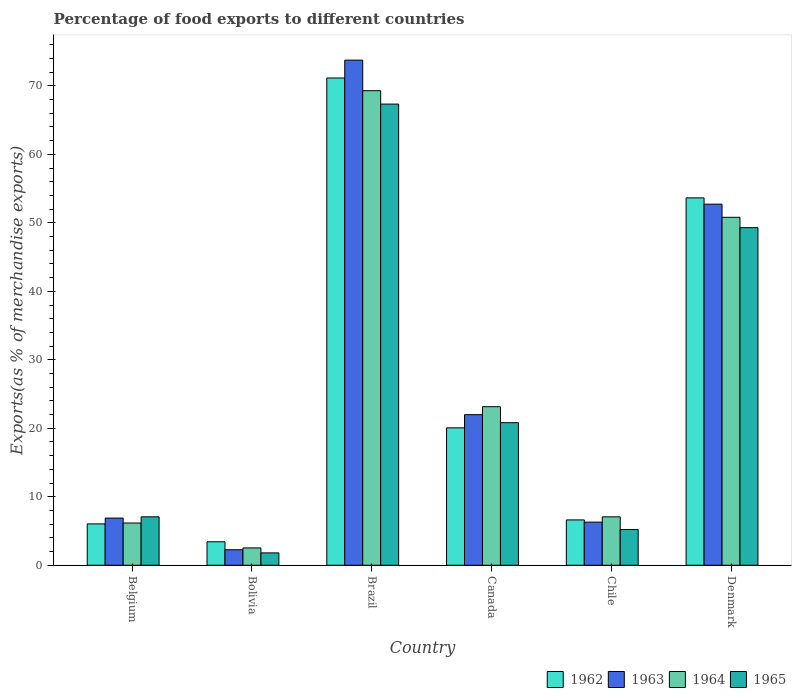Are the number of bars per tick equal to the number of legend labels?
Your answer should be compact. Yes. How many bars are there on the 1st tick from the left?
Your answer should be compact. 4. What is the label of the 2nd group of bars from the left?
Give a very brief answer. Bolivia. What is the percentage of exports to different countries in 1962 in Chile?
Your answer should be very brief. 6.62. Across all countries, what is the maximum percentage of exports to different countries in 1963?
Ensure brevity in your answer.  73.76. Across all countries, what is the minimum percentage of exports to different countries in 1962?
Provide a succinct answer. 3.43. What is the total percentage of exports to different countries in 1965 in the graph?
Your answer should be very brief. 151.55. What is the difference between the percentage of exports to different countries in 1964 in Canada and that in Denmark?
Keep it short and to the point. -27.65. What is the difference between the percentage of exports to different countries in 1962 in Belgium and the percentage of exports to different countries in 1965 in Bolivia?
Provide a succinct answer. 4.24. What is the average percentage of exports to different countries in 1962 per country?
Provide a succinct answer. 26.83. What is the difference between the percentage of exports to different countries of/in 1965 and percentage of exports to different countries of/in 1964 in Canada?
Your response must be concise. -2.34. In how many countries, is the percentage of exports to different countries in 1962 greater than 44 %?
Keep it short and to the point. 2. What is the ratio of the percentage of exports to different countries in 1964 in Bolivia to that in Denmark?
Offer a terse response. 0.05. Is the difference between the percentage of exports to different countries in 1965 in Bolivia and Brazil greater than the difference between the percentage of exports to different countries in 1964 in Bolivia and Brazil?
Your response must be concise. Yes. What is the difference between the highest and the second highest percentage of exports to different countries in 1964?
Your response must be concise. -18.49. What is the difference between the highest and the lowest percentage of exports to different countries in 1962?
Keep it short and to the point. 67.72. In how many countries, is the percentage of exports to different countries in 1965 greater than the average percentage of exports to different countries in 1965 taken over all countries?
Give a very brief answer. 2. Is the sum of the percentage of exports to different countries in 1964 in Belgium and Chile greater than the maximum percentage of exports to different countries in 1963 across all countries?
Your answer should be very brief. No. What does the 2nd bar from the right in Brazil represents?
Give a very brief answer. 1964. Is it the case that in every country, the sum of the percentage of exports to different countries in 1965 and percentage of exports to different countries in 1964 is greater than the percentage of exports to different countries in 1963?
Your answer should be compact. Yes. How many bars are there?
Offer a very short reply. 24. Are all the bars in the graph horizontal?
Your response must be concise. No. What is the difference between two consecutive major ticks on the Y-axis?
Your answer should be very brief. 10. Are the values on the major ticks of Y-axis written in scientific E-notation?
Offer a terse response. No. Where does the legend appear in the graph?
Give a very brief answer. Bottom right. How many legend labels are there?
Provide a succinct answer. 4. How are the legend labels stacked?
Your answer should be very brief. Horizontal. What is the title of the graph?
Your answer should be compact. Percentage of food exports to different countries. Does "2011" appear as one of the legend labels in the graph?
Provide a succinct answer. No. What is the label or title of the Y-axis?
Keep it short and to the point. Exports(as % of merchandise exports). What is the Exports(as % of merchandise exports) in 1962 in Belgium?
Offer a terse response. 6.04. What is the Exports(as % of merchandise exports) in 1963 in Belgium?
Your answer should be very brief. 6.89. What is the Exports(as % of merchandise exports) in 1964 in Belgium?
Your answer should be compact. 6.17. What is the Exports(as % of merchandise exports) in 1965 in Belgium?
Offer a terse response. 7.07. What is the Exports(as % of merchandise exports) in 1962 in Bolivia?
Provide a short and direct response. 3.43. What is the Exports(as % of merchandise exports) in 1963 in Bolivia?
Offer a terse response. 2.27. What is the Exports(as % of merchandise exports) in 1964 in Bolivia?
Your answer should be very brief. 2.53. What is the Exports(as % of merchandise exports) in 1965 in Bolivia?
Keep it short and to the point. 1.81. What is the Exports(as % of merchandise exports) of 1962 in Brazil?
Provide a succinct answer. 71.15. What is the Exports(as % of merchandise exports) of 1963 in Brazil?
Offer a terse response. 73.76. What is the Exports(as % of merchandise exports) of 1964 in Brazil?
Provide a succinct answer. 69.29. What is the Exports(as % of merchandise exports) in 1965 in Brazil?
Your answer should be compact. 67.34. What is the Exports(as % of merchandise exports) in 1962 in Canada?
Ensure brevity in your answer.  20.07. What is the Exports(as % of merchandise exports) in 1963 in Canada?
Provide a short and direct response. 21.99. What is the Exports(as % of merchandise exports) in 1964 in Canada?
Your response must be concise. 23.16. What is the Exports(as % of merchandise exports) in 1965 in Canada?
Offer a very short reply. 20.82. What is the Exports(as % of merchandise exports) of 1962 in Chile?
Offer a very short reply. 6.62. What is the Exports(as % of merchandise exports) in 1963 in Chile?
Ensure brevity in your answer.  6.3. What is the Exports(as % of merchandise exports) of 1964 in Chile?
Offer a very short reply. 7.07. What is the Exports(as % of merchandise exports) of 1965 in Chile?
Your answer should be very brief. 5.22. What is the Exports(as % of merchandise exports) of 1962 in Denmark?
Offer a very short reply. 53.65. What is the Exports(as % of merchandise exports) of 1963 in Denmark?
Offer a terse response. 52.73. What is the Exports(as % of merchandise exports) in 1964 in Denmark?
Offer a very short reply. 50.81. What is the Exports(as % of merchandise exports) in 1965 in Denmark?
Offer a terse response. 49.3. Across all countries, what is the maximum Exports(as % of merchandise exports) of 1962?
Your response must be concise. 71.15. Across all countries, what is the maximum Exports(as % of merchandise exports) in 1963?
Your answer should be compact. 73.76. Across all countries, what is the maximum Exports(as % of merchandise exports) in 1964?
Provide a succinct answer. 69.29. Across all countries, what is the maximum Exports(as % of merchandise exports) in 1965?
Ensure brevity in your answer.  67.34. Across all countries, what is the minimum Exports(as % of merchandise exports) in 1962?
Provide a succinct answer. 3.43. Across all countries, what is the minimum Exports(as % of merchandise exports) of 1963?
Your answer should be very brief. 2.27. Across all countries, what is the minimum Exports(as % of merchandise exports) of 1964?
Ensure brevity in your answer.  2.53. Across all countries, what is the minimum Exports(as % of merchandise exports) of 1965?
Make the answer very short. 1.81. What is the total Exports(as % of merchandise exports) of 1962 in the graph?
Make the answer very short. 160.96. What is the total Exports(as % of merchandise exports) in 1963 in the graph?
Offer a terse response. 163.93. What is the total Exports(as % of merchandise exports) of 1964 in the graph?
Provide a short and direct response. 159.03. What is the total Exports(as % of merchandise exports) in 1965 in the graph?
Your response must be concise. 151.55. What is the difference between the Exports(as % of merchandise exports) in 1962 in Belgium and that in Bolivia?
Offer a very short reply. 2.61. What is the difference between the Exports(as % of merchandise exports) in 1963 in Belgium and that in Bolivia?
Give a very brief answer. 4.62. What is the difference between the Exports(as % of merchandise exports) in 1964 in Belgium and that in Bolivia?
Provide a short and direct response. 3.64. What is the difference between the Exports(as % of merchandise exports) of 1965 in Belgium and that in Bolivia?
Provide a succinct answer. 5.27. What is the difference between the Exports(as % of merchandise exports) in 1962 in Belgium and that in Brazil?
Keep it short and to the point. -65.11. What is the difference between the Exports(as % of merchandise exports) in 1963 in Belgium and that in Brazil?
Offer a very short reply. -66.87. What is the difference between the Exports(as % of merchandise exports) of 1964 in Belgium and that in Brazil?
Provide a short and direct response. -63.12. What is the difference between the Exports(as % of merchandise exports) in 1965 in Belgium and that in Brazil?
Keep it short and to the point. -60.27. What is the difference between the Exports(as % of merchandise exports) in 1962 in Belgium and that in Canada?
Provide a succinct answer. -14.02. What is the difference between the Exports(as % of merchandise exports) of 1963 in Belgium and that in Canada?
Offer a terse response. -15.1. What is the difference between the Exports(as % of merchandise exports) in 1964 in Belgium and that in Canada?
Make the answer very short. -16.99. What is the difference between the Exports(as % of merchandise exports) in 1965 in Belgium and that in Canada?
Provide a short and direct response. -13.75. What is the difference between the Exports(as % of merchandise exports) in 1962 in Belgium and that in Chile?
Give a very brief answer. -0.58. What is the difference between the Exports(as % of merchandise exports) in 1963 in Belgium and that in Chile?
Offer a terse response. 0.59. What is the difference between the Exports(as % of merchandise exports) in 1964 in Belgium and that in Chile?
Your answer should be compact. -0.9. What is the difference between the Exports(as % of merchandise exports) in 1965 in Belgium and that in Chile?
Offer a very short reply. 1.86. What is the difference between the Exports(as % of merchandise exports) of 1962 in Belgium and that in Denmark?
Provide a succinct answer. -47.6. What is the difference between the Exports(as % of merchandise exports) of 1963 in Belgium and that in Denmark?
Provide a short and direct response. -45.84. What is the difference between the Exports(as % of merchandise exports) in 1964 in Belgium and that in Denmark?
Give a very brief answer. -44.64. What is the difference between the Exports(as % of merchandise exports) in 1965 in Belgium and that in Denmark?
Provide a succinct answer. -42.22. What is the difference between the Exports(as % of merchandise exports) in 1962 in Bolivia and that in Brazil?
Offer a very short reply. -67.72. What is the difference between the Exports(as % of merchandise exports) in 1963 in Bolivia and that in Brazil?
Provide a succinct answer. -71.49. What is the difference between the Exports(as % of merchandise exports) of 1964 in Bolivia and that in Brazil?
Give a very brief answer. -66.76. What is the difference between the Exports(as % of merchandise exports) in 1965 in Bolivia and that in Brazil?
Your response must be concise. -65.53. What is the difference between the Exports(as % of merchandise exports) of 1962 in Bolivia and that in Canada?
Make the answer very short. -16.64. What is the difference between the Exports(as % of merchandise exports) of 1963 in Bolivia and that in Canada?
Ensure brevity in your answer.  -19.72. What is the difference between the Exports(as % of merchandise exports) in 1964 in Bolivia and that in Canada?
Offer a terse response. -20.62. What is the difference between the Exports(as % of merchandise exports) of 1965 in Bolivia and that in Canada?
Make the answer very short. -19.01. What is the difference between the Exports(as % of merchandise exports) in 1962 in Bolivia and that in Chile?
Your response must be concise. -3.19. What is the difference between the Exports(as % of merchandise exports) of 1963 in Bolivia and that in Chile?
Make the answer very short. -4.03. What is the difference between the Exports(as % of merchandise exports) of 1964 in Bolivia and that in Chile?
Make the answer very short. -4.54. What is the difference between the Exports(as % of merchandise exports) of 1965 in Bolivia and that in Chile?
Make the answer very short. -3.41. What is the difference between the Exports(as % of merchandise exports) in 1962 in Bolivia and that in Denmark?
Make the answer very short. -50.22. What is the difference between the Exports(as % of merchandise exports) of 1963 in Bolivia and that in Denmark?
Ensure brevity in your answer.  -50.46. What is the difference between the Exports(as % of merchandise exports) of 1964 in Bolivia and that in Denmark?
Your answer should be very brief. -48.27. What is the difference between the Exports(as % of merchandise exports) in 1965 in Bolivia and that in Denmark?
Offer a very short reply. -47.49. What is the difference between the Exports(as % of merchandise exports) in 1962 in Brazil and that in Canada?
Ensure brevity in your answer.  51.08. What is the difference between the Exports(as % of merchandise exports) of 1963 in Brazil and that in Canada?
Give a very brief answer. 51.77. What is the difference between the Exports(as % of merchandise exports) in 1964 in Brazil and that in Canada?
Ensure brevity in your answer.  46.14. What is the difference between the Exports(as % of merchandise exports) of 1965 in Brazil and that in Canada?
Make the answer very short. 46.52. What is the difference between the Exports(as % of merchandise exports) of 1962 in Brazil and that in Chile?
Offer a very short reply. 64.53. What is the difference between the Exports(as % of merchandise exports) of 1963 in Brazil and that in Chile?
Give a very brief answer. 67.46. What is the difference between the Exports(as % of merchandise exports) in 1964 in Brazil and that in Chile?
Offer a terse response. 62.22. What is the difference between the Exports(as % of merchandise exports) in 1965 in Brazil and that in Chile?
Your answer should be compact. 62.12. What is the difference between the Exports(as % of merchandise exports) in 1962 in Brazil and that in Denmark?
Your answer should be compact. 17.5. What is the difference between the Exports(as % of merchandise exports) in 1963 in Brazil and that in Denmark?
Give a very brief answer. 21.03. What is the difference between the Exports(as % of merchandise exports) in 1964 in Brazil and that in Denmark?
Ensure brevity in your answer.  18.49. What is the difference between the Exports(as % of merchandise exports) of 1965 in Brazil and that in Denmark?
Your response must be concise. 18.04. What is the difference between the Exports(as % of merchandise exports) of 1962 in Canada and that in Chile?
Make the answer very short. 13.45. What is the difference between the Exports(as % of merchandise exports) in 1963 in Canada and that in Chile?
Offer a very short reply. 15.69. What is the difference between the Exports(as % of merchandise exports) of 1964 in Canada and that in Chile?
Your answer should be compact. 16.09. What is the difference between the Exports(as % of merchandise exports) in 1965 in Canada and that in Chile?
Your response must be concise. 15.6. What is the difference between the Exports(as % of merchandise exports) of 1962 in Canada and that in Denmark?
Ensure brevity in your answer.  -33.58. What is the difference between the Exports(as % of merchandise exports) of 1963 in Canada and that in Denmark?
Offer a very short reply. -30.74. What is the difference between the Exports(as % of merchandise exports) of 1964 in Canada and that in Denmark?
Keep it short and to the point. -27.65. What is the difference between the Exports(as % of merchandise exports) of 1965 in Canada and that in Denmark?
Provide a short and direct response. -28.48. What is the difference between the Exports(as % of merchandise exports) of 1962 in Chile and that in Denmark?
Your answer should be very brief. -47.02. What is the difference between the Exports(as % of merchandise exports) in 1963 in Chile and that in Denmark?
Offer a terse response. -46.43. What is the difference between the Exports(as % of merchandise exports) in 1964 in Chile and that in Denmark?
Offer a very short reply. -43.74. What is the difference between the Exports(as % of merchandise exports) of 1965 in Chile and that in Denmark?
Make the answer very short. -44.08. What is the difference between the Exports(as % of merchandise exports) in 1962 in Belgium and the Exports(as % of merchandise exports) in 1963 in Bolivia?
Ensure brevity in your answer.  3.78. What is the difference between the Exports(as % of merchandise exports) in 1962 in Belgium and the Exports(as % of merchandise exports) in 1964 in Bolivia?
Offer a very short reply. 3.51. What is the difference between the Exports(as % of merchandise exports) in 1962 in Belgium and the Exports(as % of merchandise exports) in 1965 in Bolivia?
Provide a short and direct response. 4.24. What is the difference between the Exports(as % of merchandise exports) of 1963 in Belgium and the Exports(as % of merchandise exports) of 1964 in Bolivia?
Offer a terse response. 4.36. What is the difference between the Exports(as % of merchandise exports) of 1963 in Belgium and the Exports(as % of merchandise exports) of 1965 in Bolivia?
Your answer should be compact. 5.08. What is the difference between the Exports(as % of merchandise exports) in 1964 in Belgium and the Exports(as % of merchandise exports) in 1965 in Bolivia?
Your response must be concise. 4.36. What is the difference between the Exports(as % of merchandise exports) in 1962 in Belgium and the Exports(as % of merchandise exports) in 1963 in Brazil?
Give a very brief answer. -67.71. What is the difference between the Exports(as % of merchandise exports) in 1962 in Belgium and the Exports(as % of merchandise exports) in 1964 in Brazil?
Make the answer very short. -63.25. What is the difference between the Exports(as % of merchandise exports) of 1962 in Belgium and the Exports(as % of merchandise exports) of 1965 in Brazil?
Offer a terse response. -61.3. What is the difference between the Exports(as % of merchandise exports) of 1963 in Belgium and the Exports(as % of merchandise exports) of 1964 in Brazil?
Make the answer very short. -62.4. What is the difference between the Exports(as % of merchandise exports) in 1963 in Belgium and the Exports(as % of merchandise exports) in 1965 in Brazil?
Offer a very short reply. -60.45. What is the difference between the Exports(as % of merchandise exports) of 1964 in Belgium and the Exports(as % of merchandise exports) of 1965 in Brazil?
Ensure brevity in your answer.  -61.17. What is the difference between the Exports(as % of merchandise exports) of 1962 in Belgium and the Exports(as % of merchandise exports) of 1963 in Canada?
Give a very brief answer. -15.95. What is the difference between the Exports(as % of merchandise exports) of 1962 in Belgium and the Exports(as % of merchandise exports) of 1964 in Canada?
Your response must be concise. -17.11. What is the difference between the Exports(as % of merchandise exports) in 1962 in Belgium and the Exports(as % of merchandise exports) in 1965 in Canada?
Your answer should be very brief. -14.78. What is the difference between the Exports(as % of merchandise exports) in 1963 in Belgium and the Exports(as % of merchandise exports) in 1964 in Canada?
Your answer should be compact. -16.27. What is the difference between the Exports(as % of merchandise exports) of 1963 in Belgium and the Exports(as % of merchandise exports) of 1965 in Canada?
Your answer should be compact. -13.93. What is the difference between the Exports(as % of merchandise exports) of 1964 in Belgium and the Exports(as % of merchandise exports) of 1965 in Canada?
Provide a succinct answer. -14.65. What is the difference between the Exports(as % of merchandise exports) in 1962 in Belgium and the Exports(as % of merchandise exports) in 1963 in Chile?
Your response must be concise. -0.26. What is the difference between the Exports(as % of merchandise exports) of 1962 in Belgium and the Exports(as % of merchandise exports) of 1964 in Chile?
Ensure brevity in your answer.  -1.03. What is the difference between the Exports(as % of merchandise exports) in 1962 in Belgium and the Exports(as % of merchandise exports) in 1965 in Chile?
Make the answer very short. 0.83. What is the difference between the Exports(as % of merchandise exports) in 1963 in Belgium and the Exports(as % of merchandise exports) in 1964 in Chile?
Provide a succinct answer. -0.18. What is the difference between the Exports(as % of merchandise exports) in 1963 in Belgium and the Exports(as % of merchandise exports) in 1965 in Chile?
Give a very brief answer. 1.67. What is the difference between the Exports(as % of merchandise exports) in 1964 in Belgium and the Exports(as % of merchandise exports) in 1965 in Chile?
Keep it short and to the point. 0.95. What is the difference between the Exports(as % of merchandise exports) in 1962 in Belgium and the Exports(as % of merchandise exports) in 1963 in Denmark?
Provide a succinct answer. -46.69. What is the difference between the Exports(as % of merchandise exports) in 1962 in Belgium and the Exports(as % of merchandise exports) in 1964 in Denmark?
Offer a very short reply. -44.76. What is the difference between the Exports(as % of merchandise exports) in 1962 in Belgium and the Exports(as % of merchandise exports) in 1965 in Denmark?
Ensure brevity in your answer.  -43.25. What is the difference between the Exports(as % of merchandise exports) of 1963 in Belgium and the Exports(as % of merchandise exports) of 1964 in Denmark?
Offer a terse response. -43.92. What is the difference between the Exports(as % of merchandise exports) in 1963 in Belgium and the Exports(as % of merchandise exports) in 1965 in Denmark?
Your answer should be compact. -42.41. What is the difference between the Exports(as % of merchandise exports) in 1964 in Belgium and the Exports(as % of merchandise exports) in 1965 in Denmark?
Keep it short and to the point. -43.13. What is the difference between the Exports(as % of merchandise exports) of 1962 in Bolivia and the Exports(as % of merchandise exports) of 1963 in Brazil?
Offer a terse response. -70.33. What is the difference between the Exports(as % of merchandise exports) in 1962 in Bolivia and the Exports(as % of merchandise exports) in 1964 in Brazil?
Your answer should be compact. -65.86. What is the difference between the Exports(as % of merchandise exports) in 1962 in Bolivia and the Exports(as % of merchandise exports) in 1965 in Brazil?
Your answer should be compact. -63.91. What is the difference between the Exports(as % of merchandise exports) in 1963 in Bolivia and the Exports(as % of merchandise exports) in 1964 in Brazil?
Make the answer very short. -67.03. What is the difference between the Exports(as % of merchandise exports) of 1963 in Bolivia and the Exports(as % of merchandise exports) of 1965 in Brazil?
Give a very brief answer. -65.07. What is the difference between the Exports(as % of merchandise exports) of 1964 in Bolivia and the Exports(as % of merchandise exports) of 1965 in Brazil?
Offer a very short reply. -64.81. What is the difference between the Exports(as % of merchandise exports) in 1962 in Bolivia and the Exports(as % of merchandise exports) in 1963 in Canada?
Offer a very short reply. -18.56. What is the difference between the Exports(as % of merchandise exports) in 1962 in Bolivia and the Exports(as % of merchandise exports) in 1964 in Canada?
Your response must be concise. -19.73. What is the difference between the Exports(as % of merchandise exports) in 1962 in Bolivia and the Exports(as % of merchandise exports) in 1965 in Canada?
Provide a short and direct response. -17.39. What is the difference between the Exports(as % of merchandise exports) in 1963 in Bolivia and the Exports(as % of merchandise exports) in 1964 in Canada?
Provide a succinct answer. -20.89. What is the difference between the Exports(as % of merchandise exports) in 1963 in Bolivia and the Exports(as % of merchandise exports) in 1965 in Canada?
Provide a short and direct response. -18.55. What is the difference between the Exports(as % of merchandise exports) in 1964 in Bolivia and the Exports(as % of merchandise exports) in 1965 in Canada?
Provide a short and direct response. -18.29. What is the difference between the Exports(as % of merchandise exports) of 1962 in Bolivia and the Exports(as % of merchandise exports) of 1963 in Chile?
Your answer should be very brief. -2.87. What is the difference between the Exports(as % of merchandise exports) in 1962 in Bolivia and the Exports(as % of merchandise exports) in 1964 in Chile?
Ensure brevity in your answer.  -3.64. What is the difference between the Exports(as % of merchandise exports) in 1962 in Bolivia and the Exports(as % of merchandise exports) in 1965 in Chile?
Your answer should be very brief. -1.79. What is the difference between the Exports(as % of merchandise exports) of 1963 in Bolivia and the Exports(as % of merchandise exports) of 1964 in Chile?
Your response must be concise. -4.8. What is the difference between the Exports(as % of merchandise exports) in 1963 in Bolivia and the Exports(as % of merchandise exports) in 1965 in Chile?
Give a very brief answer. -2.95. What is the difference between the Exports(as % of merchandise exports) in 1964 in Bolivia and the Exports(as % of merchandise exports) in 1965 in Chile?
Make the answer very short. -2.69. What is the difference between the Exports(as % of merchandise exports) in 1962 in Bolivia and the Exports(as % of merchandise exports) in 1963 in Denmark?
Ensure brevity in your answer.  -49.3. What is the difference between the Exports(as % of merchandise exports) in 1962 in Bolivia and the Exports(as % of merchandise exports) in 1964 in Denmark?
Keep it short and to the point. -47.38. What is the difference between the Exports(as % of merchandise exports) of 1962 in Bolivia and the Exports(as % of merchandise exports) of 1965 in Denmark?
Make the answer very short. -45.87. What is the difference between the Exports(as % of merchandise exports) of 1963 in Bolivia and the Exports(as % of merchandise exports) of 1964 in Denmark?
Give a very brief answer. -48.54. What is the difference between the Exports(as % of merchandise exports) of 1963 in Bolivia and the Exports(as % of merchandise exports) of 1965 in Denmark?
Keep it short and to the point. -47.03. What is the difference between the Exports(as % of merchandise exports) of 1964 in Bolivia and the Exports(as % of merchandise exports) of 1965 in Denmark?
Keep it short and to the point. -46.77. What is the difference between the Exports(as % of merchandise exports) in 1962 in Brazil and the Exports(as % of merchandise exports) in 1963 in Canada?
Keep it short and to the point. 49.16. What is the difference between the Exports(as % of merchandise exports) of 1962 in Brazil and the Exports(as % of merchandise exports) of 1964 in Canada?
Provide a short and direct response. 47.99. What is the difference between the Exports(as % of merchandise exports) of 1962 in Brazil and the Exports(as % of merchandise exports) of 1965 in Canada?
Provide a succinct answer. 50.33. What is the difference between the Exports(as % of merchandise exports) of 1963 in Brazil and the Exports(as % of merchandise exports) of 1964 in Canada?
Your response must be concise. 50.6. What is the difference between the Exports(as % of merchandise exports) in 1963 in Brazil and the Exports(as % of merchandise exports) in 1965 in Canada?
Your answer should be compact. 52.94. What is the difference between the Exports(as % of merchandise exports) in 1964 in Brazil and the Exports(as % of merchandise exports) in 1965 in Canada?
Give a very brief answer. 48.48. What is the difference between the Exports(as % of merchandise exports) of 1962 in Brazil and the Exports(as % of merchandise exports) of 1963 in Chile?
Ensure brevity in your answer.  64.85. What is the difference between the Exports(as % of merchandise exports) in 1962 in Brazil and the Exports(as % of merchandise exports) in 1964 in Chile?
Keep it short and to the point. 64.08. What is the difference between the Exports(as % of merchandise exports) of 1962 in Brazil and the Exports(as % of merchandise exports) of 1965 in Chile?
Offer a very short reply. 65.93. What is the difference between the Exports(as % of merchandise exports) of 1963 in Brazil and the Exports(as % of merchandise exports) of 1964 in Chile?
Ensure brevity in your answer.  66.69. What is the difference between the Exports(as % of merchandise exports) in 1963 in Brazil and the Exports(as % of merchandise exports) in 1965 in Chile?
Provide a short and direct response. 68.54. What is the difference between the Exports(as % of merchandise exports) of 1964 in Brazil and the Exports(as % of merchandise exports) of 1965 in Chile?
Provide a short and direct response. 64.08. What is the difference between the Exports(as % of merchandise exports) in 1962 in Brazil and the Exports(as % of merchandise exports) in 1963 in Denmark?
Your answer should be compact. 18.42. What is the difference between the Exports(as % of merchandise exports) in 1962 in Brazil and the Exports(as % of merchandise exports) in 1964 in Denmark?
Keep it short and to the point. 20.34. What is the difference between the Exports(as % of merchandise exports) in 1962 in Brazil and the Exports(as % of merchandise exports) in 1965 in Denmark?
Give a very brief answer. 21.85. What is the difference between the Exports(as % of merchandise exports) of 1963 in Brazil and the Exports(as % of merchandise exports) of 1964 in Denmark?
Give a very brief answer. 22.95. What is the difference between the Exports(as % of merchandise exports) of 1963 in Brazil and the Exports(as % of merchandise exports) of 1965 in Denmark?
Give a very brief answer. 24.46. What is the difference between the Exports(as % of merchandise exports) of 1964 in Brazil and the Exports(as % of merchandise exports) of 1965 in Denmark?
Offer a terse response. 20. What is the difference between the Exports(as % of merchandise exports) of 1962 in Canada and the Exports(as % of merchandise exports) of 1963 in Chile?
Provide a succinct answer. 13.77. What is the difference between the Exports(as % of merchandise exports) in 1962 in Canada and the Exports(as % of merchandise exports) in 1964 in Chile?
Make the answer very short. 13. What is the difference between the Exports(as % of merchandise exports) of 1962 in Canada and the Exports(as % of merchandise exports) of 1965 in Chile?
Provide a succinct answer. 14.85. What is the difference between the Exports(as % of merchandise exports) in 1963 in Canada and the Exports(as % of merchandise exports) in 1964 in Chile?
Give a very brief answer. 14.92. What is the difference between the Exports(as % of merchandise exports) of 1963 in Canada and the Exports(as % of merchandise exports) of 1965 in Chile?
Keep it short and to the point. 16.77. What is the difference between the Exports(as % of merchandise exports) in 1964 in Canada and the Exports(as % of merchandise exports) in 1965 in Chile?
Make the answer very short. 17.94. What is the difference between the Exports(as % of merchandise exports) of 1962 in Canada and the Exports(as % of merchandise exports) of 1963 in Denmark?
Ensure brevity in your answer.  -32.66. What is the difference between the Exports(as % of merchandise exports) in 1962 in Canada and the Exports(as % of merchandise exports) in 1964 in Denmark?
Keep it short and to the point. -30.74. What is the difference between the Exports(as % of merchandise exports) in 1962 in Canada and the Exports(as % of merchandise exports) in 1965 in Denmark?
Offer a terse response. -29.23. What is the difference between the Exports(as % of merchandise exports) of 1963 in Canada and the Exports(as % of merchandise exports) of 1964 in Denmark?
Ensure brevity in your answer.  -28.82. What is the difference between the Exports(as % of merchandise exports) of 1963 in Canada and the Exports(as % of merchandise exports) of 1965 in Denmark?
Make the answer very short. -27.31. What is the difference between the Exports(as % of merchandise exports) of 1964 in Canada and the Exports(as % of merchandise exports) of 1965 in Denmark?
Keep it short and to the point. -26.14. What is the difference between the Exports(as % of merchandise exports) in 1962 in Chile and the Exports(as % of merchandise exports) in 1963 in Denmark?
Keep it short and to the point. -46.11. What is the difference between the Exports(as % of merchandise exports) in 1962 in Chile and the Exports(as % of merchandise exports) in 1964 in Denmark?
Make the answer very short. -44.19. What is the difference between the Exports(as % of merchandise exports) of 1962 in Chile and the Exports(as % of merchandise exports) of 1965 in Denmark?
Your response must be concise. -42.68. What is the difference between the Exports(as % of merchandise exports) in 1963 in Chile and the Exports(as % of merchandise exports) in 1964 in Denmark?
Give a very brief answer. -44.51. What is the difference between the Exports(as % of merchandise exports) of 1963 in Chile and the Exports(as % of merchandise exports) of 1965 in Denmark?
Offer a terse response. -43. What is the difference between the Exports(as % of merchandise exports) in 1964 in Chile and the Exports(as % of merchandise exports) in 1965 in Denmark?
Make the answer very short. -42.23. What is the average Exports(as % of merchandise exports) of 1962 per country?
Keep it short and to the point. 26.83. What is the average Exports(as % of merchandise exports) in 1963 per country?
Provide a succinct answer. 27.32. What is the average Exports(as % of merchandise exports) in 1964 per country?
Keep it short and to the point. 26.5. What is the average Exports(as % of merchandise exports) of 1965 per country?
Make the answer very short. 25.26. What is the difference between the Exports(as % of merchandise exports) in 1962 and Exports(as % of merchandise exports) in 1963 in Belgium?
Offer a terse response. -0.85. What is the difference between the Exports(as % of merchandise exports) in 1962 and Exports(as % of merchandise exports) in 1964 in Belgium?
Offer a terse response. -0.13. What is the difference between the Exports(as % of merchandise exports) in 1962 and Exports(as % of merchandise exports) in 1965 in Belgium?
Provide a succinct answer. -1.03. What is the difference between the Exports(as % of merchandise exports) of 1963 and Exports(as % of merchandise exports) of 1964 in Belgium?
Your response must be concise. 0.72. What is the difference between the Exports(as % of merchandise exports) in 1963 and Exports(as % of merchandise exports) in 1965 in Belgium?
Make the answer very short. -0.18. What is the difference between the Exports(as % of merchandise exports) of 1964 and Exports(as % of merchandise exports) of 1965 in Belgium?
Make the answer very short. -0.9. What is the difference between the Exports(as % of merchandise exports) in 1962 and Exports(as % of merchandise exports) in 1963 in Bolivia?
Your answer should be very brief. 1.16. What is the difference between the Exports(as % of merchandise exports) of 1962 and Exports(as % of merchandise exports) of 1964 in Bolivia?
Give a very brief answer. 0.9. What is the difference between the Exports(as % of merchandise exports) in 1962 and Exports(as % of merchandise exports) in 1965 in Bolivia?
Provide a short and direct response. 1.62. What is the difference between the Exports(as % of merchandise exports) in 1963 and Exports(as % of merchandise exports) in 1964 in Bolivia?
Make the answer very short. -0.27. What is the difference between the Exports(as % of merchandise exports) of 1963 and Exports(as % of merchandise exports) of 1965 in Bolivia?
Make the answer very short. 0.46. What is the difference between the Exports(as % of merchandise exports) of 1964 and Exports(as % of merchandise exports) of 1965 in Bolivia?
Make the answer very short. 0.73. What is the difference between the Exports(as % of merchandise exports) of 1962 and Exports(as % of merchandise exports) of 1963 in Brazil?
Ensure brevity in your answer.  -2.61. What is the difference between the Exports(as % of merchandise exports) of 1962 and Exports(as % of merchandise exports) of 1964 in Brazil?
Keep it short and to the point. 1.86. What is the difference between the Exports(as % of merchandise exports) in 1962 and Exports(as % of merchandise exports) in 1965 in Brazil?
Provide a succinct answer. 3.81. What is the difference between the Exports(as % of merchandise exports) of 1963 and Exports(as % of merchandise exports) of 1964 in Brazil?
Keep it short and to the point. 4.46. What is the difference between the Exports(as % of merchandise exports) of 1963 and Exports(as % of merchandise exports) of 1965 in Brazil?
Offer a very short reply. 6.42. What is the difference between the Exports(as % of merchandise exports) of 1964 and Exports(as % of merchandise exports) of 1965 in Brazil?
Offer a very short reply. 1.96. What is the difference between the Exports(as % of merchandise exports) of 1962 and Exports(as % of merchandise exports) of 1963 in Canada?
Make the answer very short. -1.92. What is the difference between the Exports(as % of merchandise exports) in 1962 and Exports(as % of merchandise exports) in 1964 in Canada?
Offer a very short reply. -3.09. What is the difference between the Exports(as % of merchandise exports) in 1962 and Exports(as % of merchandise exports) in 1965 in Canada?
Provide a short and direct response. -0.75. What is the difference between the Exports(as % of merchandise exports) of 1963 and Exports(as % of merchandise exports) of 1964 in Canada?
Your answer should be compact. -1.17. What is the difference between the Exports(as % of merchandise exports) in 1963 and Exports(as % of merchandise exports) in 1965 in Canada?
Offer a very short reply. 1.17. What is the difference between the Exports(as % of merchandise exports) of 1964 and Exports(as % of merchandise exports) of 1965 in Canada?
Offer a very short reply. 2.34. What is the difference between the Exports(as % of merchandise exports) of 1962 and Exports(as % of merchandise exports) of 1963 in Chile?
Offer a terse response. 0.32. What is the difference between the Exports(as % of merchandise exports) in 1962 and Exports(as % of merchandise exports) in 1964 in Chile?
Offer a terse response. -0.45. What is the difference between the Exports(as % of merchandise exports) of 1962 and Exports(as % of merchandise exports) of 1965 in Chile?
Provide a succinct answer. 1.4. What is the difference between the Exports(as % of merchandise exports) of 1963 and Exports(as % of merchandise exports) of 1964 in Chile?
Ensure brevity in your answer.  -0.77. What is the difference between the Exports(as % of merchandise exports) in 1963 and Exports(as % of merchandise exports) in 1965 in Chile?
Offer a very short reply. 1.08. What is the difference between the Exports(as % of merchandise exports) of 1964 and Exports(as % of merchandise exports) of 1965 in Chile?
Provide a succinct answer. 1.85. What is the difference between the Exports(as % of merchandise exports) in 1962 and Exports(as % of merchandise exports) in 1963 in Denmark?
Provide a succinct answer. 0.92. What is the difference between the Exports(as % of merchandise exports) of 1962 and Exports(as % of merchandise exports) of 1964 in Denmark?
Offer a very short reply. 2.84. What is the difference between the Exports(as % of merchandise exports) of 1962 and Exports(as % of merchandise exports) of 1965 in Denmark?
Your answer should be very brief. 4.35. What is the difference between the Exports(as % of merchandise exports) in 1963 and Exports(as % of merchandise exports) in 1964 in Denmark?
Ensure brevity in your answer.  1.92. What is the difference between the Exports(as % of merchandise exports) in 1963 and Exports(as % of merchandise exports) in 1965 in Denmark?
Make the answer very short. 3.43. What is the difference between the Exports(as % of merchandise exports) in 1964 and Exports(as % of merchandise exports) in 1965 in Denmark?
Make the answer very short. 1.51. What is the ratio of the Exports(as % of merchandise exports) of 1962 in Belgium to that in Bolivia?
Keep it short and to the point. 1.76. What is the ratio of the Exports(as % of merchandise exports) of 1963 in Belgium to that in Bolivia?
Make the answer very short. 3.04. What is the ratio of the Exports(as % of merchandise exports) in 1964 in Belgium to that in Bolivia?
Offer a terse response. 2.44. What is the ratio of the Exports(as % of merchandise exports) in 1965 in Belgium to that in Bolivia?
Make the answer very short. 3.91. What is the ratio of the Exports(as % of merchandise exports) in 1962 in Belgium to that in Brazil?
Provide a succinct answer. 0.08. What is the ratio of the Exports(as % of merchandise exports) in 1963 in Belgium to that in Brazil?
Your answer should be very brief. 0.09. What is the ratio of the Exports(as % of merchandise exports) in 1964 in Belgium to that in Brazil?
Keep it short and to the point. 0.09. What is the ratio of the Exports(as % of merchandise exports) in 1965 in Belgium to that in Brazil?
Ensure brevity in your answer.  0.1. What is the ratio of the Exports(as % of merchandise exports) of 1962 in Belgium to that in Canada?
Offer a terse response. 0.3. What is the ratio of the Exports(as % of merchandise exports) in 1963 in Belgium to that in Canada?
Give a very brief answer. 0.31. What is the ratio of the Exports(as % of merchandise exports) in 1964 in Belgium to that in Canada?
Your answer should be very brief. 0.27. What is the ratio of the Exports(as % of merchandise exports) of 1965 in Belgium to that in Canada?
Provide a short and direct response. 0.34. What is the ratio of the Exports(as % of merchandise exports) in 1962 in Belgium to that in Chile?
Ensure brevity in your answer.  0.91. What is the ratio of the Exports(as % of merchandise exports) of 1963 in Belgium to that in Chile?
Your answer should be compact. 1.09. What is the ratio of the Exports(as % of merchandise exports) in 1964 in Belgium to that in Chile?
Your answer should be very brief. 0.87. What is the ratio of the Exports(as % of merchandise exports) of 1965 in Belgium to that in Chile?
Make the answer very short. 1.36. What is the ratio of the Exports(as % of merchandise exports) of 1962 in Belgium to that in Denmark?
Make the answer very short. 0.11. What is the ratio of the Exports(as % of merchandise exports) in 1963 in Belgium to that in Denmark?
Ensure brevity in your answer.  0.13. What is the ratio of the Exports(as % of merchandise exports) of 1964 in Belgium to that in Denmark?
Your response must be concise. 0.12. What is the ratio of the Exports(as % of merchandise exports) of 1965 in Belgium to that in Denmark?
Provide a succinct answer. 0.14. What is the ratio of the Exports(as % of merchandise exports) of 1962 in Bolivia to that in Brazil?
Make the answer very short. 0.05. What is the ratio of the Exports(as % of merchandise exports) of 1963 in Bolivia to that in Brazil?
Your answer should be compact. 0.03. What is the ratio of the Exports(as % of merchandise exports) in 1964 in Bolivia to that in Brazil?
Make the answer very short. 0.04. What is the ratio of the Exports(as % of merchandise exports) in 1965 in Bolivia to that in Brazil?
Ensure brevity in your answer.  0.03. What is the ratio of the Exports(as % of merchandise exports) of 1962 in Bolivia to that in Canada?
Your answer should be compact. 0.17. What is the ratio of the Exports(as % of merchandise exports) of 1963 in Bolivia to that in Canada?
Provide a short and direct response. 0.1. What is the ratio of the Exports(as % of merchandise exports) in 1964 in Bolivia to that in Canada?
Offer a terse response. 0.11. What is the ratio of the Exports(as % of merchandise exports) in 1965 in Bolivia to that in Canada?
Make the answer very short. 0.09. What is the ratio of the Exports(as % of merchandise exports) in 1962 in Bolivia to that in Chile?
Your answer should be very brief. 0.52. What is the ratio of the Exports(as % of merchandise exports) of 1963 in Bolivia to that in Chile?
Provide a succinct answer. 0.36. What is the ratio of the Exports(as % of merchandise exports) in 1964 in Bolivia to that in Chile?
Offer a terse response. 0.36. What is the ratio of the Exports(as % of merchandise exports) in 1965 in Bolivia to that in Chile?
Your answer should be compact. 0.35. What is the ratio of the Exports(as % of merchandise exports) of 1962 in Bolivia to that in Denmark?
Make the answer very short. 0.06. What is the ratio of the Exports(as % of merchandise exports) in 1963 in Bolivia to that in Denmark?
Your answer should be very brief. 0.04. What is the ratio of the Exports(as % of merchandise exports) in 1964 in Bolivia to that in Denmark?
Give a very brief answer. 0.05. What is the ratio of the Exports(as % of merchandise exports) of 1965 in Bolivia to that in Denmark?
Your response must be concise. 0.04. What is the ratio of the Exports(as % of merchandise exports) in 1962 in Brazil to that in Canada?
Offer a very short reply. 3.55. What is the ratio of the Exports(as % of merchandise exports) of 1963 in Brazil to that in Canada?
Make the answer very short. 3.35. What is the ratio of the Exports(as % of merchandise exports) in 1964 in Brazil to that in Canada?
Your answer should be very brief. 2.99. What is the ratio of the Exports(as % of merchandise exports) of 1965 in Brazil to that in Canada?
Provide a short and direct response. 3.23. What is the ratio of the Exports(as % of merchandise exports) in 1962 in Brazil to that in Chile?
Offer a terse response. 10.75. What is the ratio of the Exports(as % of merchandise exports) in 1963 in Brazil to that in Chile?
Offer a very short reply. 11.71. What is the ratio of the Exports(as % of merchandise exports) in 1964 in Brazil to that in Chile?
Ensure brevity in your answer.  9.8. What is the ratio of the Exports(as % of merchandise exports) in 1965 in Brazil to that in Chile?
Your answer should be compact. 12.91. What is the ratio of the Exports(as % of merchandise exports) of 1962 in Brazil to that in Denmark?
Offer a very short reply. 1.33. What is the ratio of the Exports(as % of merchandise exports) of 1963 in Brazil to that in Denmark?
Keep it short and to the point. 1.4. What is the ratio of the Exports(as % of merchandise exports) of 1964 in Brazil to that in Denmark?
Your response must be concise. 1.36. What is the ratio of the Exports(as % of merchandise exports) in 1965 in Brazil to that in Denmark?
Provide a short and direct response. 1.37. What is the ratio of the Exports(as % of merchandise exports) of 1962 in Canada to that in Chile?
Your response must be concise. 3.03. What is the ratio of the Exports(as % of merchandise exports) in 1963 in Canada to that in Chile?
Your response must be concise. 3.49. What is the ratio of the Exports(as % of merchandise exports) in 1964 in Canada to that in Chile?
Your answer should be compact. 3.28. What is the ratio of the Exports(as % of merchandise exports) of 1965 in Canada to that in Chile?
Your answer should be very brief. 3.99. What is the ratio of the Exports(as % of merchandise exports) of 1962 in Canada to that in Denmark?
Make the answer very short. 0.37. What is the ratio of the Exports(as % of merchandise exports) in 1963 in Canada to that in Denmark?
Your answer should be compact. 0.42. What is the ratio of the Exports(as % of merchandise exports) of 1964 in Canada to that in Denmark?
Ensure brevity in your answer.  0.46. What is the ratio of the Exports(as % of merchandise exports) in 1965 in Canada to that in Denmark?
Offer a very short reply. 0.42. What is the ratio of the Exports(as % of merchandise exports) of 1962 in Chile to that in Denmark?
Your answer should be compact. 0.12. What is the ratio of the Exports(as % of merchandise exports) in 1963 in Chile to that in Denmark?
Your answer should be very brief. 0.12. What is the ratio of the Exports(as % of merchandise exports) of 1964 in Chile to that in Denmark?
Keep it short and to the point. 0.14. What is the ratio of the Exports(as % of merchandise exports) in 1965 in Chile to that in Denmark?
Offer a very short reply. 0.11. What is the difference between the highest and the second highest Exports(as % of merchandise exports) in 1962?
Offer a terse response. 17.5. What is the difference between the highest and the second highest Exports(as % of merchandise exports) of 1963?
Provide a short and direct response. 21.03. What is the difference between the highest and the second highest Exports(as % of merchandise exports) in 1964?
Your answer should be very brief. 18.49. What is the difference between the highest and the second highest Exports(as % of merchandise exports) in 1965?
Offer a terse response. 18.04. What is the difference between the highest and the lowest Exports(as % of merchandise exports) of 1962?
Offer a very short reply. 67.72. What is the difference between the highest and the lowest Exports(as % of merchandise exports) of 1963?
Offer a very short reply. 71.49. What is the difference between the highest and the lowest Exports(as % of merchandise exports) in 1964?
Offer a very short reply. 66.76. What is the difference between the highest and the lowest Exports(as % of merchandise exports) of 1965?
Give a very brief answer. 65.53. 